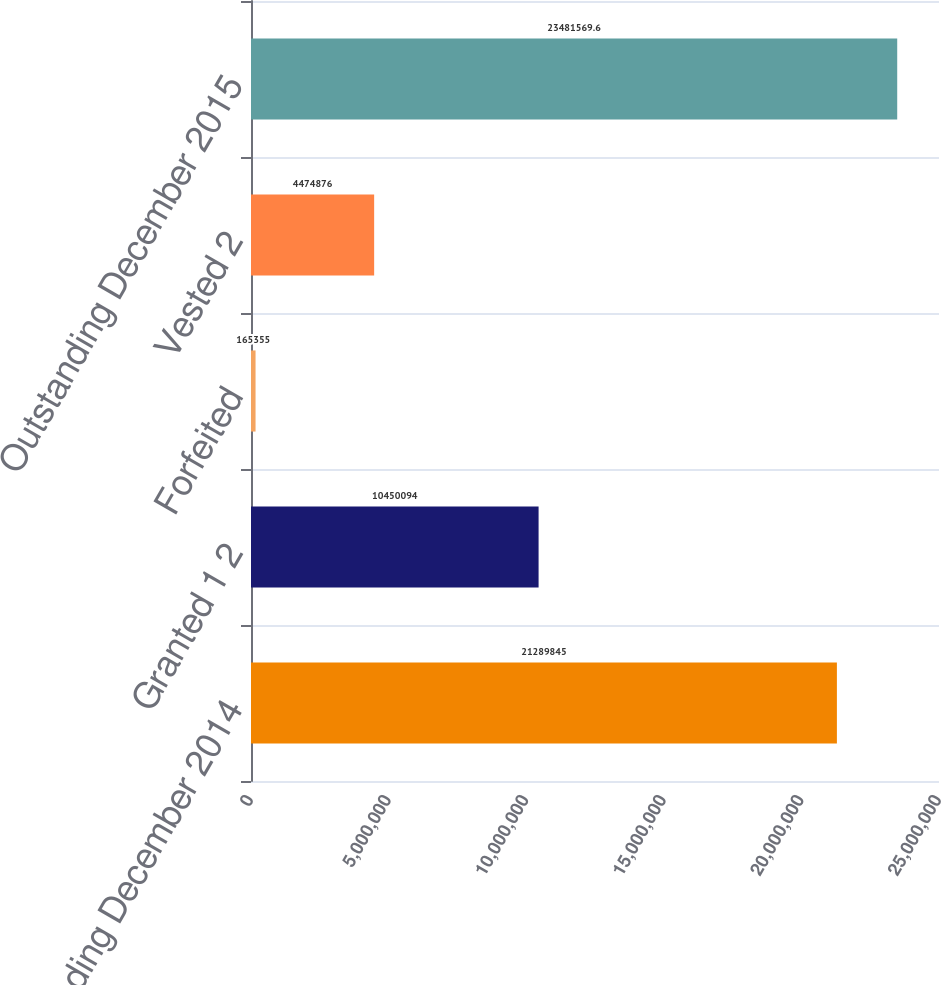<chart> <loc_0><loc_0><loc_500><loc_500><bar_chart><fcel>Outstanding December 2014<fcel>Granted 1 2<fcel>Forfeited<fcel>Vested 2<fcel>Outstanding December 2015<nl><fcel>2.12898e+07<fcel>1.04501e+07<fcel>165355<fcel>4.47488e+06<fcel>2.34816e+07<nl></chart> 